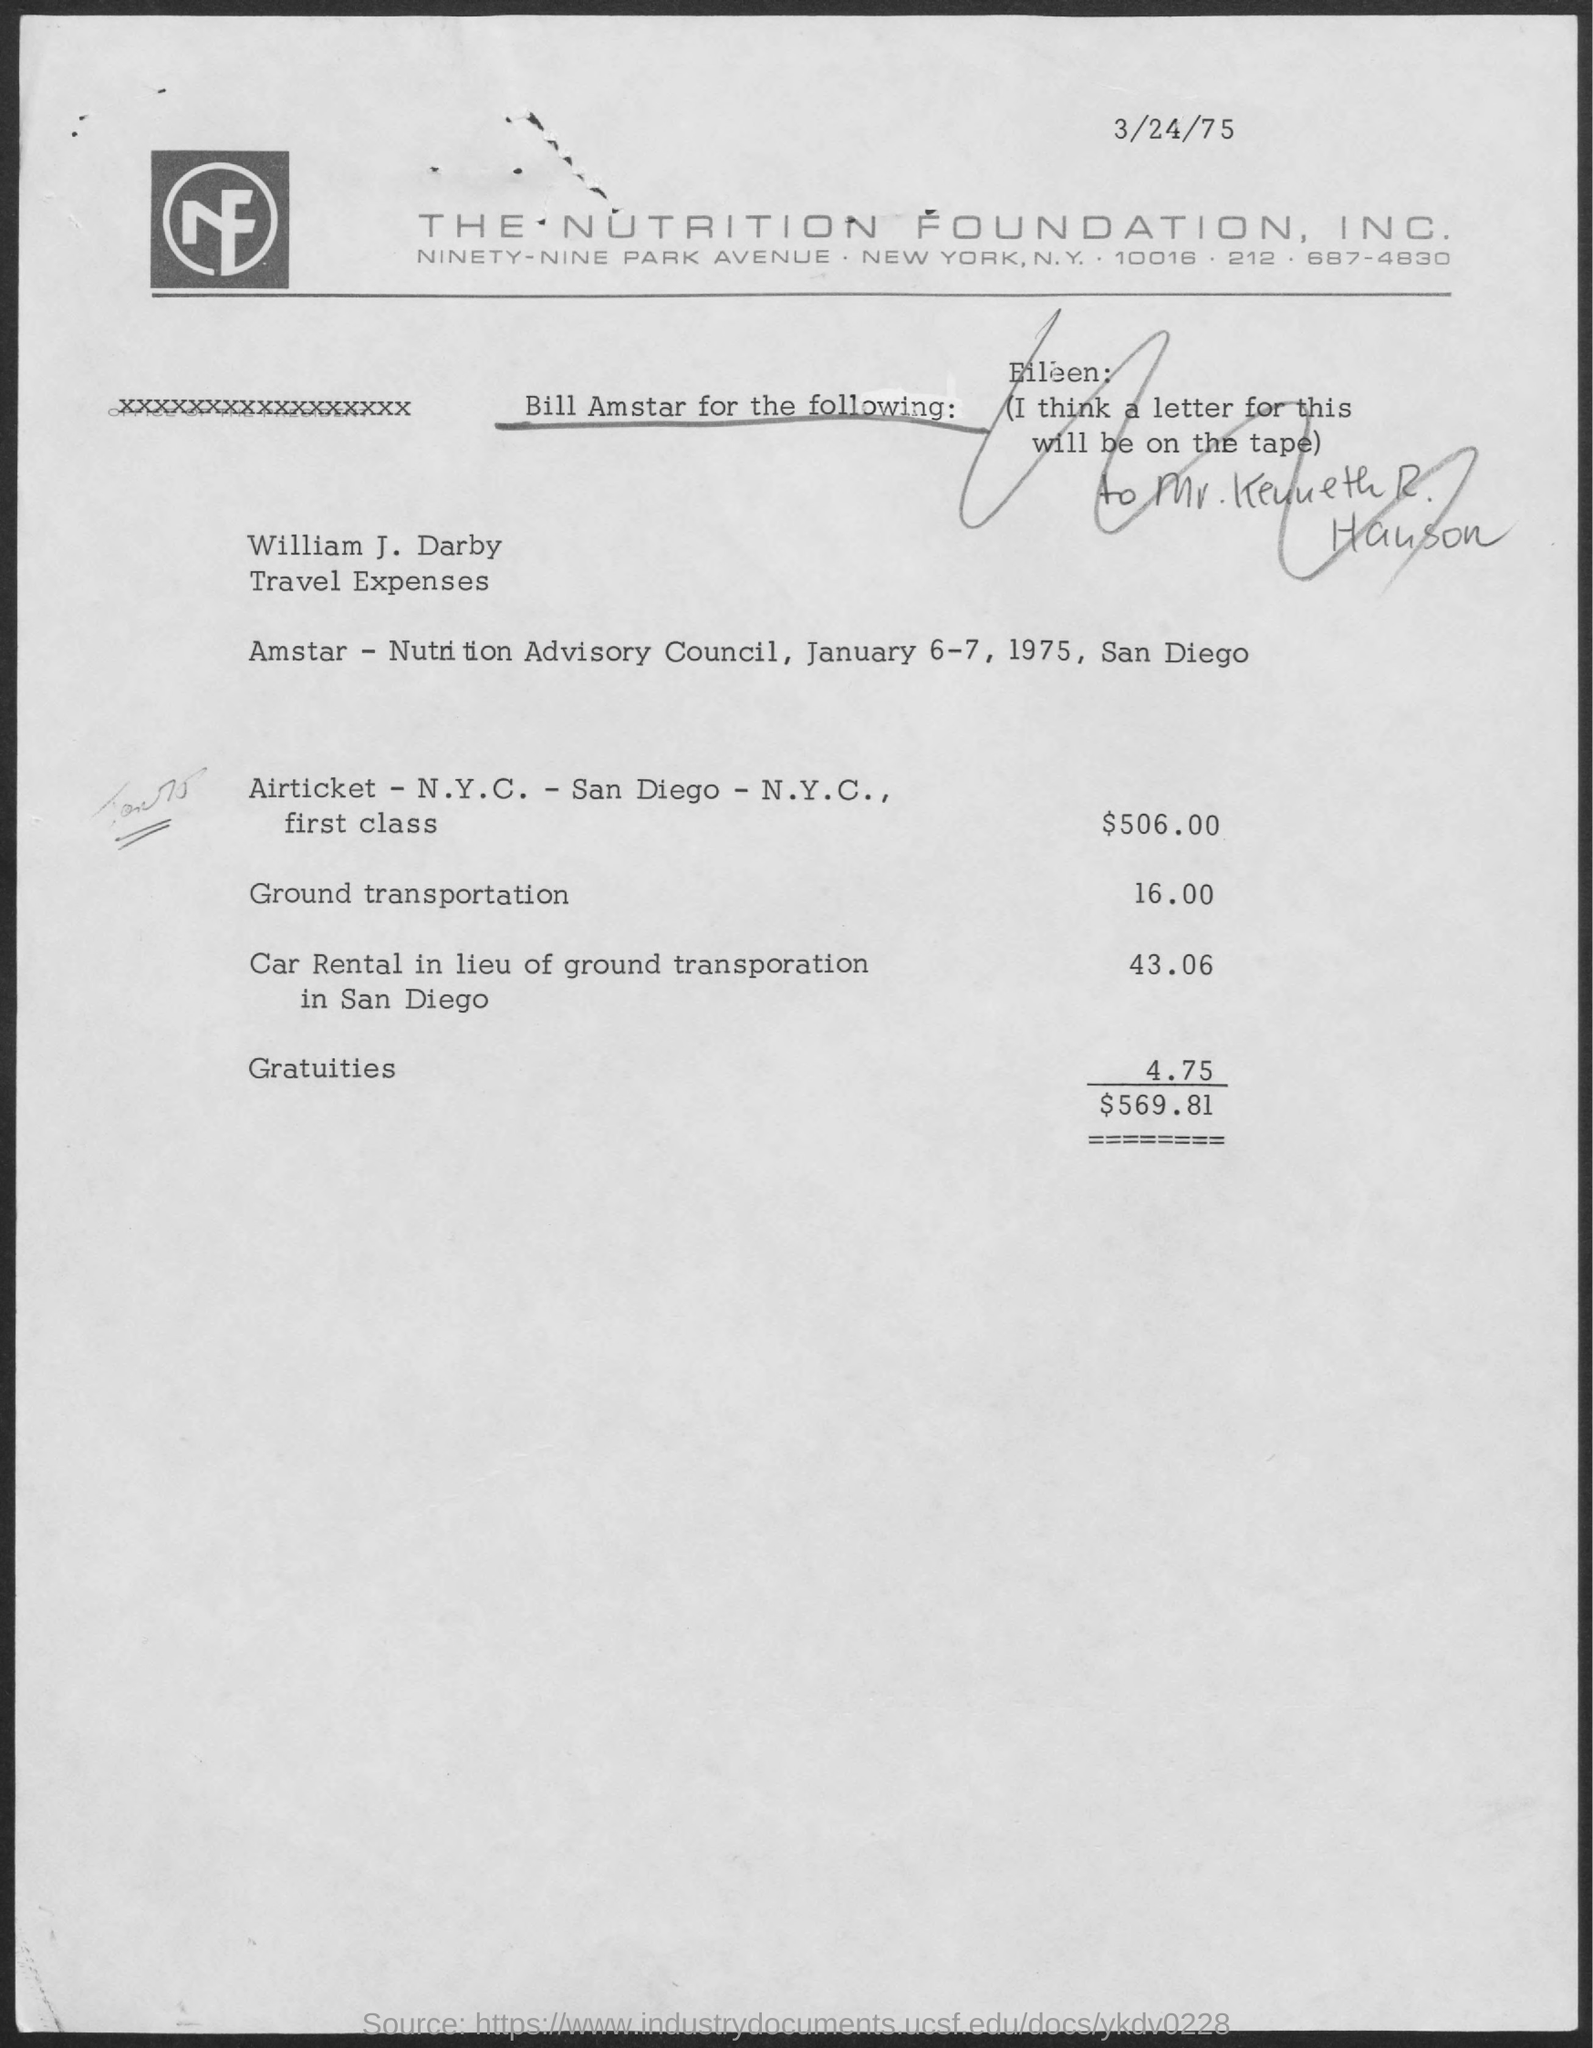What is the date mentioned in the top of the document ?
Give a very brief answer. 3/24/75. What is written in the letter head ?
Offer a very short reply. THE NUTRITION FOUNDATION, INC. 